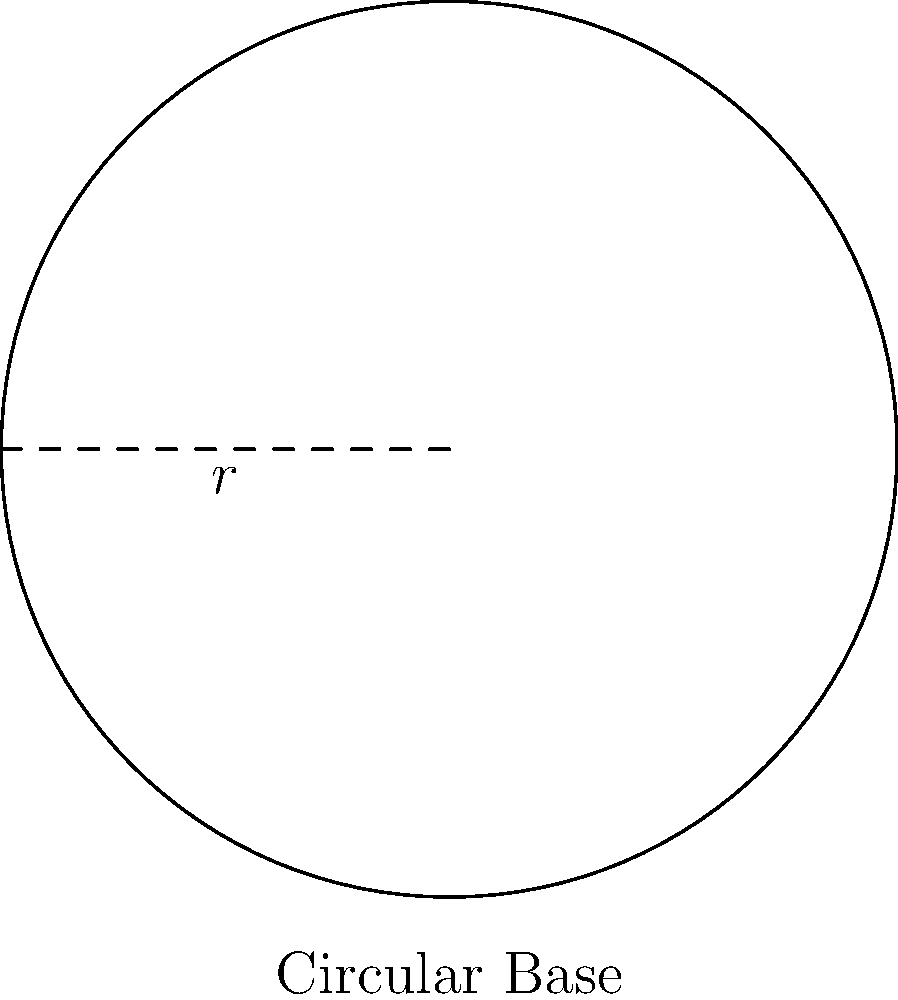You are designing a new chess-playing robot with a circular base. The radius of the base is 30 cm. To ensure proper cable management, you need to install a protective strip along the entire perimeter of the base. How many centimeters of protective strip do you need to cover the entire perimeter? To solve this problem, we need to calculate the circumference of the circular base:

1. The formula for the circumference of a circle is $C = 2\pi r$, where $r$ is the radius.

2. We are given that the radius is 30 cm.

3. Let's substitute the values into the formula:
   $C = 2\pi \cdot 30$

4. Simplify:
   $C = 60\pi$ cm

5. To get a decimal approximation, we can use $\pi \approx 3.14159$:
   $C \approx 60 \cdot 3.14159 \approx 188.50$ cm

Therefore, you need approximately 188.50 cm of protective strip to cover the entire perimeter of the robot's circular base.
Answer: $188.50$ cm 